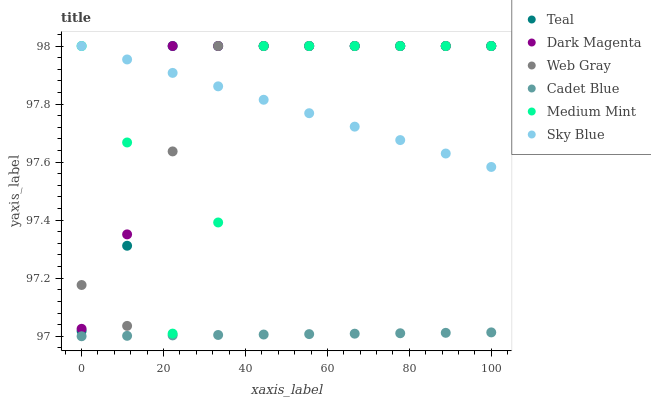Does Cadet Blue have the minimum area under the curve?
Answer yes or no. Yes. Does Dark Magenta have the maximum area under the curve?
Answer yes or no. Yes. Does Dark Magenta have the minimum area under the curve?
Answer yes or no. No. Does Cadet Blue have the maximum area under the curve?
Answer yes or no. No. Is Sky Blue the smoothest?
Answer yes or no. Yes. Is Medium Mint the roughest?
Answer yes or no. Yes. Is Cadet Blue the smoothest?
Answer yes or no. No. Is Cadet Blue the roughest?
Answer yes or no. No. Does Cadet Blue have the lowest value?
Answer yes or no. Yes. Does Dark Magenta have the lowest value?
Answer yes or no. No. Does Sky Blue have the highest value?
Answer yes or no. Yes. Does Cadet Blue have the highest value?
Answer yes or no. No. Is Cadet Blue less than Web Gray?
Answer yes or no. Yes. Is Sky Blue greater than Cadet Blue?
Answer yes or no. Yes. Does Dark Magenta intersect Web Gray?
Answer yes or no. Yes. Is Dark Magenta less than Web Gray?
Answer yes or no. No. Is Dark Magenta greater than Web Gray?
Answer yes or no. No. Does Cadet Blue intersect Web Gray?
Answer yes or no. No. 